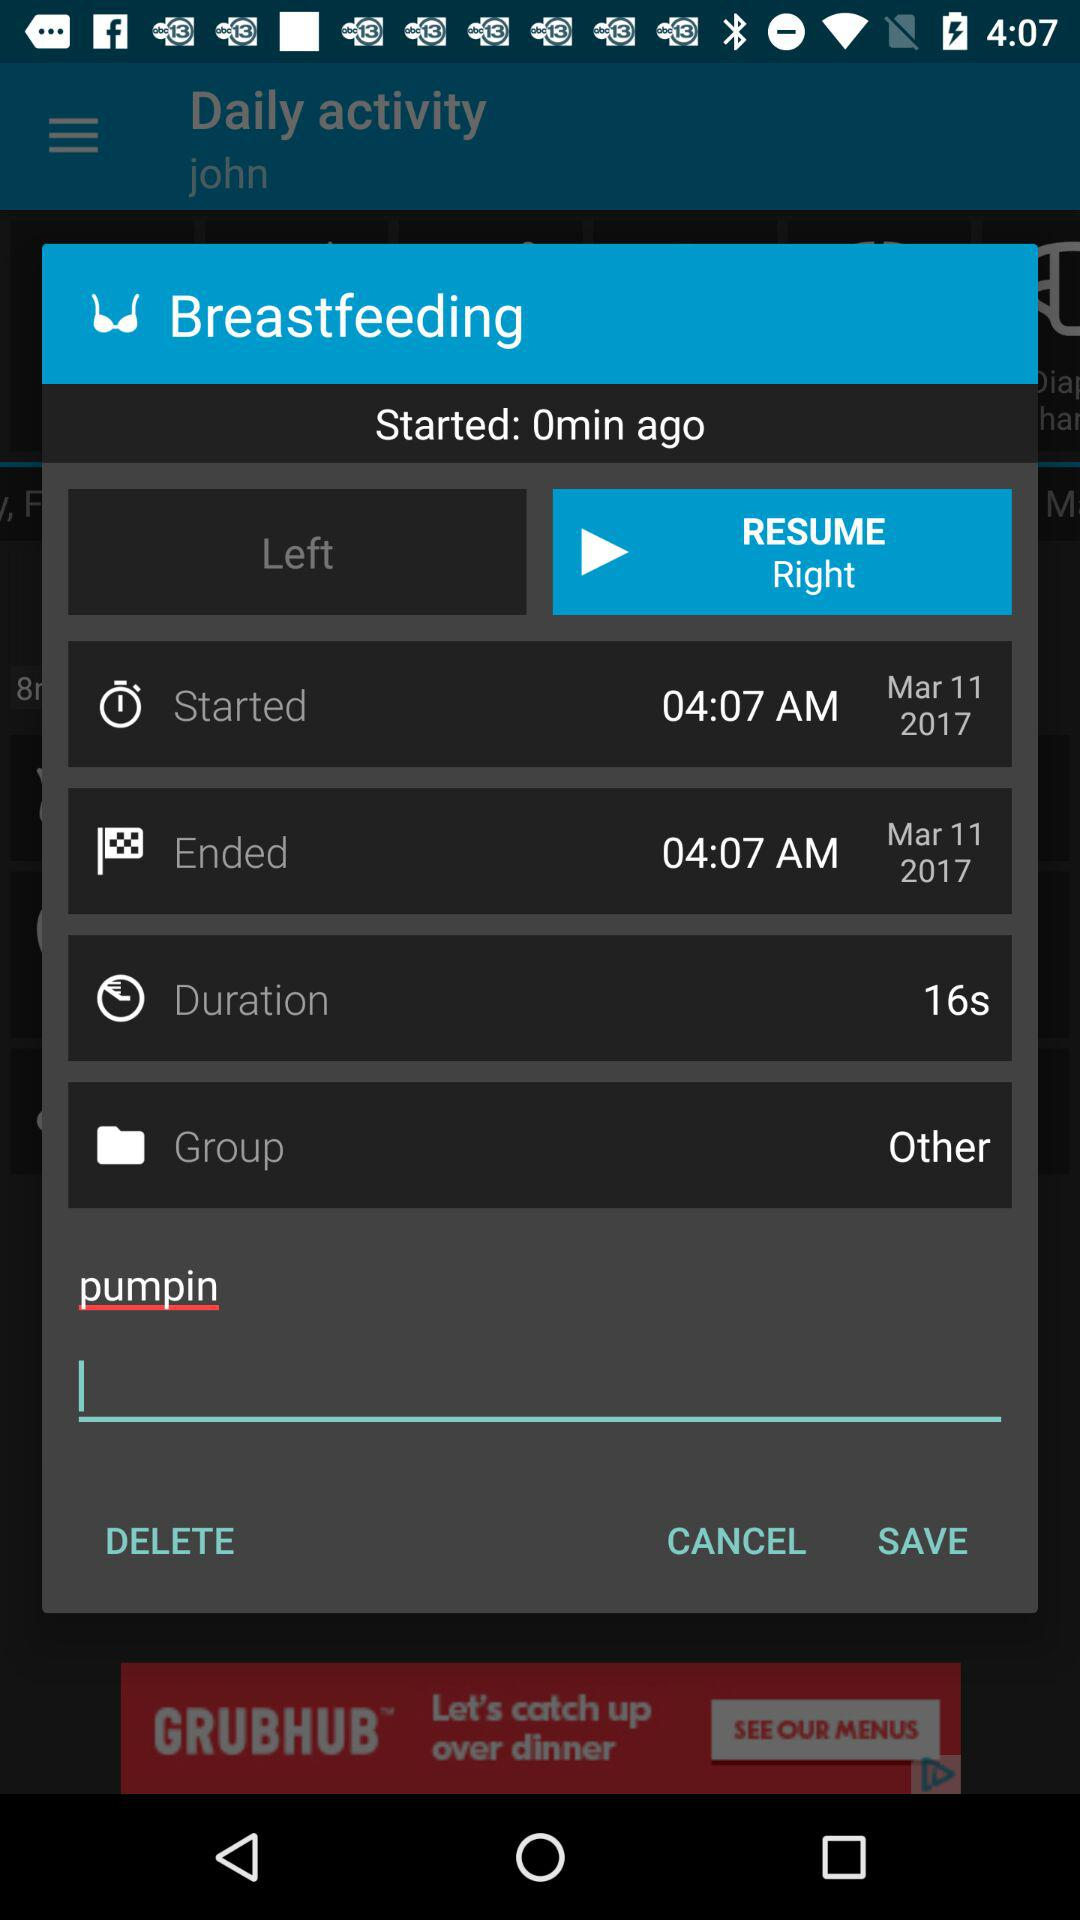What is the duration? The duration is 16 seconds. 